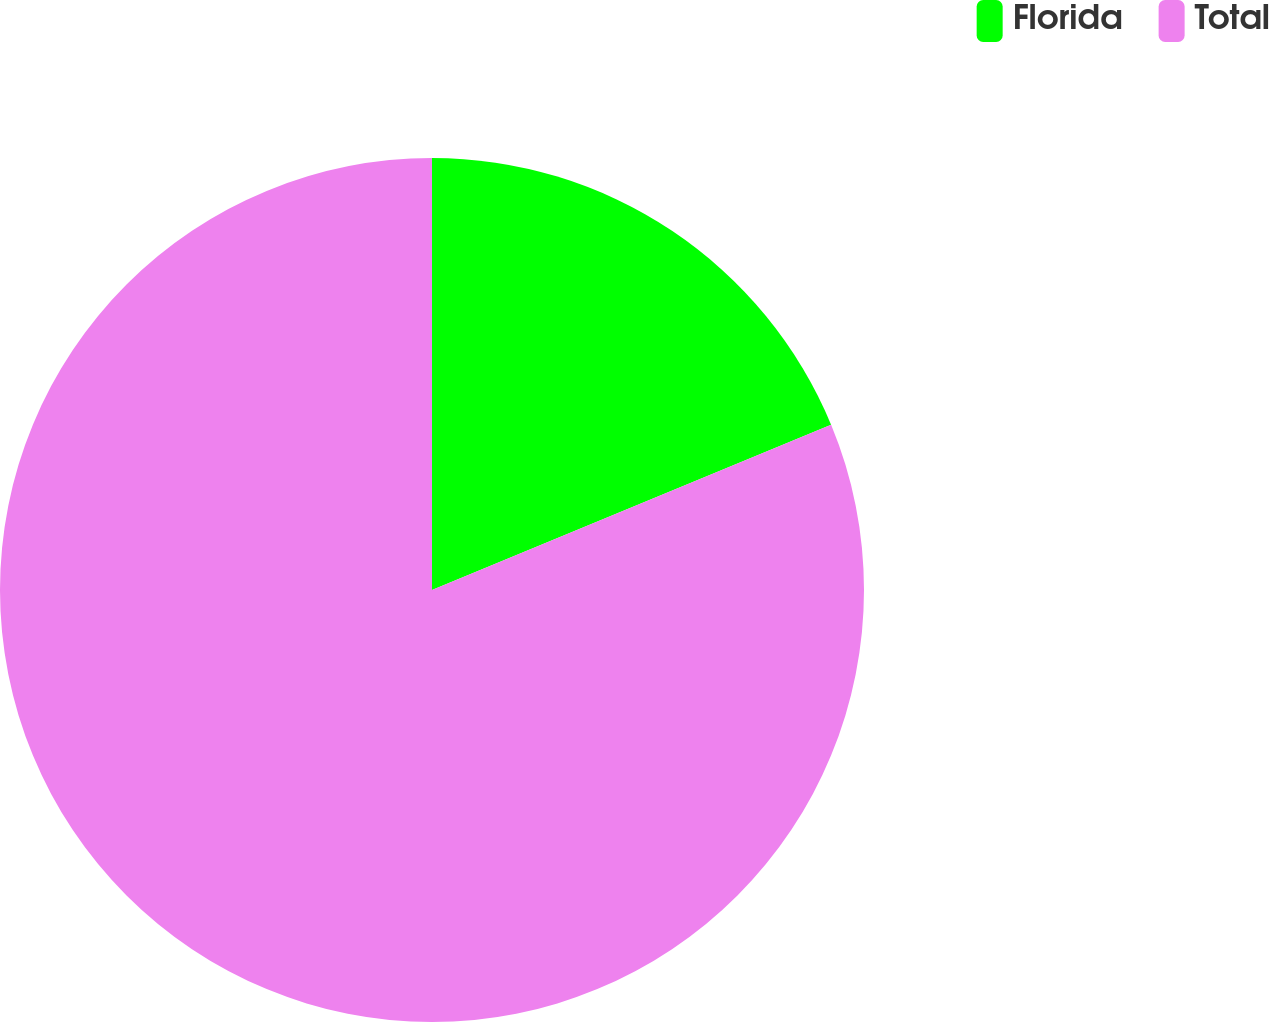Convert chart. <chart><loc_0><loc_0><loc_500><loc_500><pie_chart><fcel>Florida<fcel>Total<nl><fcel>18.75%<fcel>81.25%<nl></chart> 